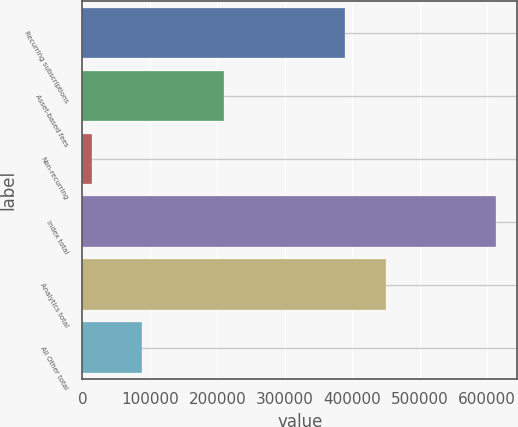Convert chart to OTSL. <chart><loc_0><loc_0><loc_500><loc_500><bar_chart><fcel>Recurring subscriptions<fcel>Asset-based fees<fcel>Non-recurring<fcel>Index total<fcel>Analytics total<fcel>All Other total<nl><fcel>389348<fcel>210229<fcel>13974<fcel>613551<fcel>449306<fcel>88765<nl></chart> 